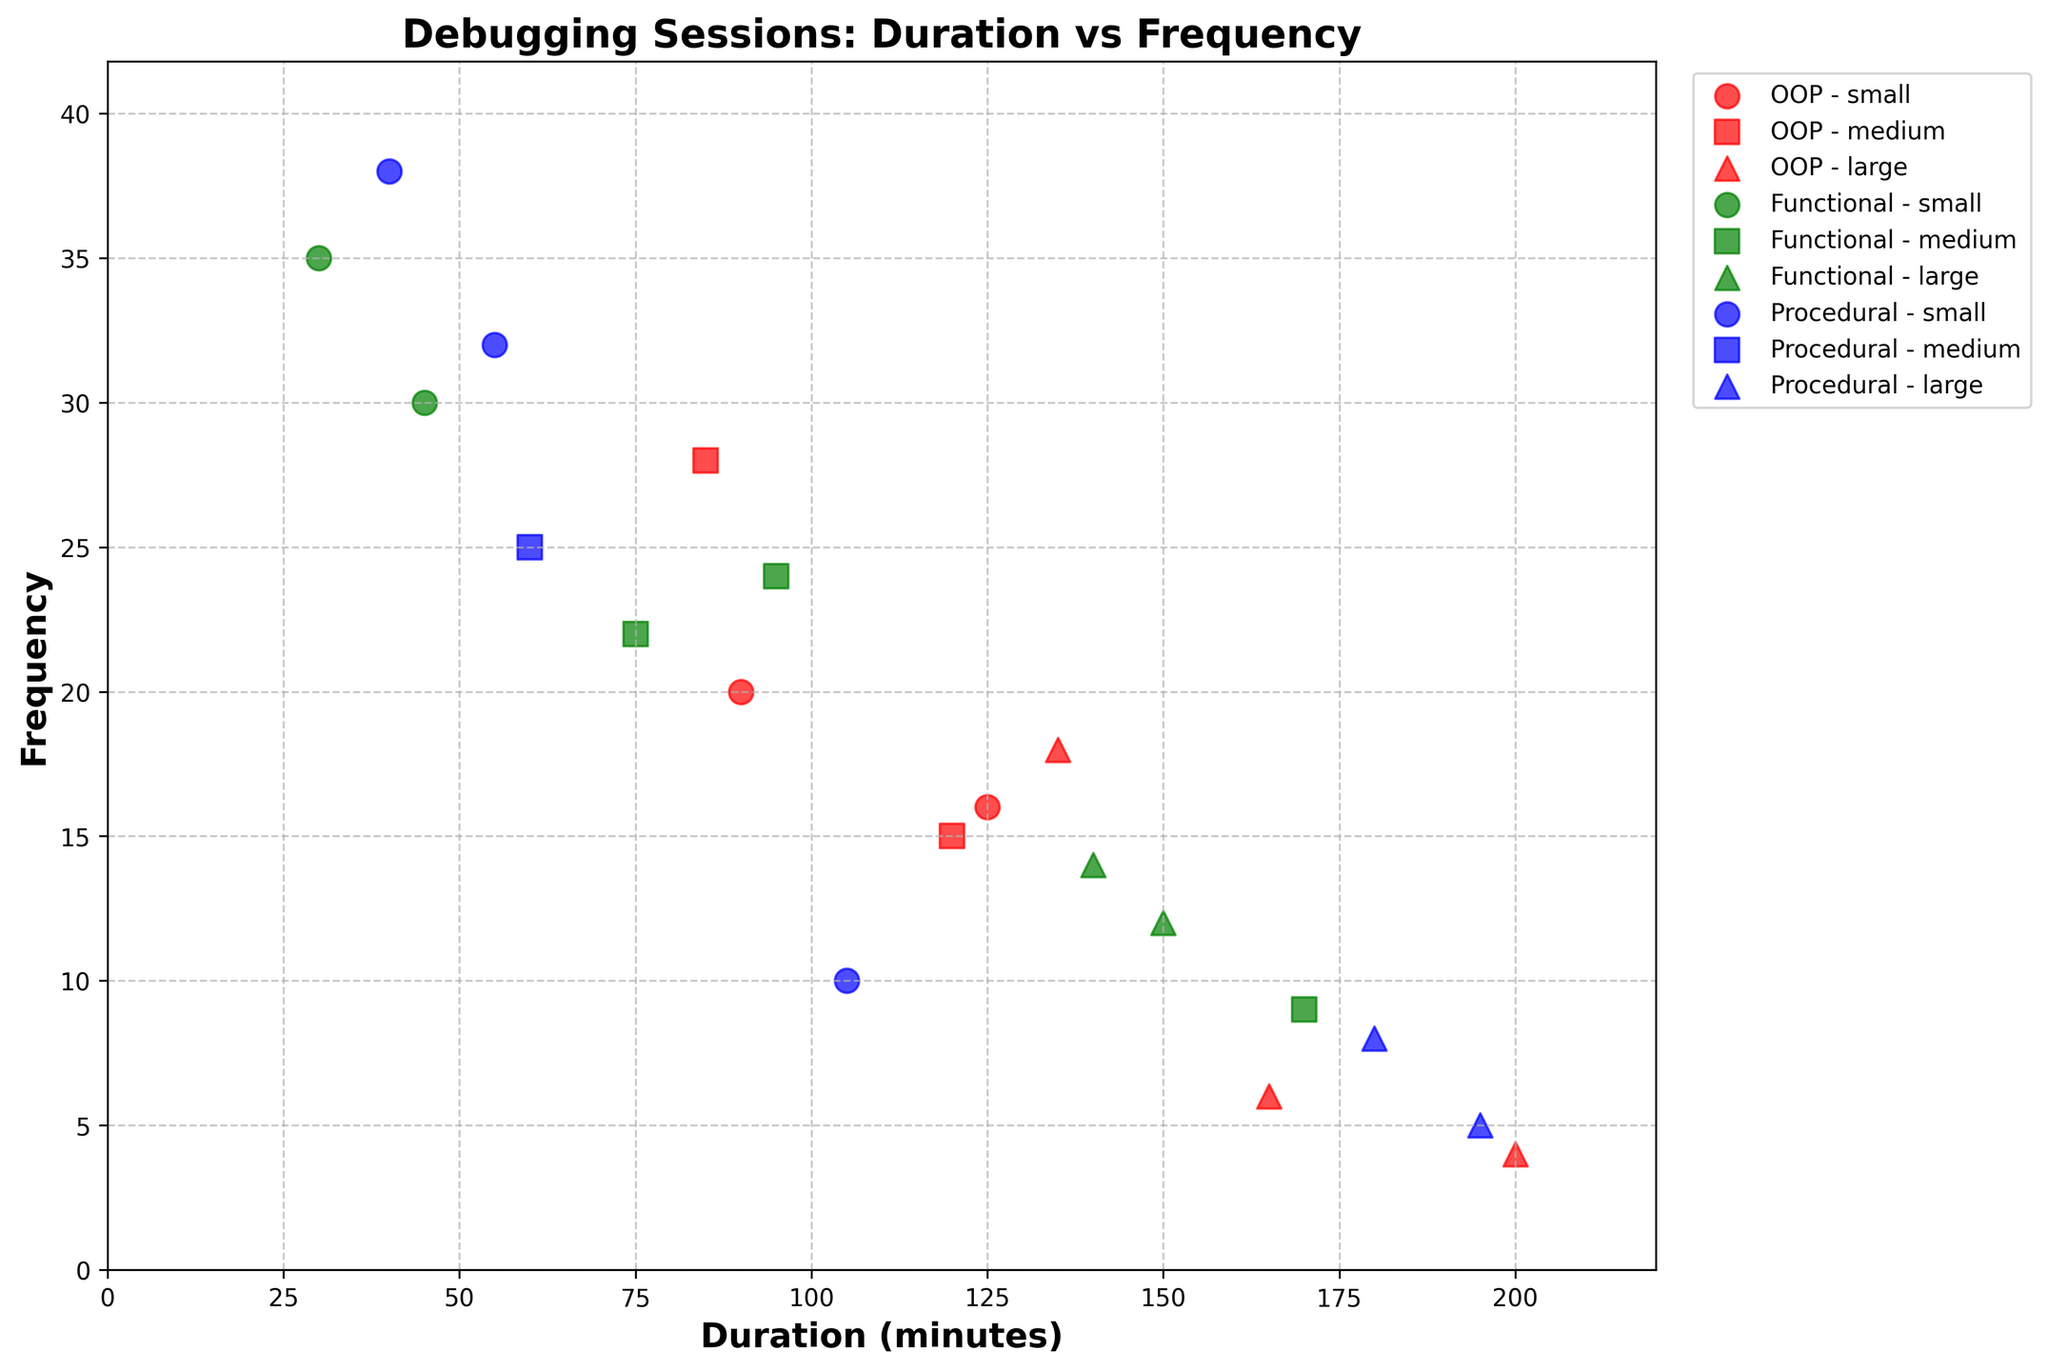What is the title of the plot? The title of the plot is typically located at the top center of the figure. By reading this area, we can identify the title easily.
Answer: Debugging Sessions: Duration vs Frequency How many unique colors are used to represent different programming paradigms? By looking at the different colors used in the plot, and since three paradigms are plotted, we can count the number of unique colors used.
Answer: Three Which programming paradigm generally has the highest debugging frequency? From the plot, we can observe the frequencies on the vertical axis and note the points where they are highest. Then, we check which colored markers represent these points.
Answer: Functional What is the range of durations for Procedural programming projects? By examining the x-axis values corresponding to the blue markers (Procedural), we can identify the minimum and maximum values for these points.
Answer: 30 to 200 Which project size in OOP has the highest debugging frequency? First, identify the red markers (OOP) and note down the shapes representing different project sizes. Then find the point with the highest frequency.
Answer: Medium What's the average frequency of debugging sessions for small Functional programming projects? Locate the green 'o' markers for small Functional projects, sum their frequencies, and divide by the number of such points. (30 + 35) / 2 = 32.5
Answer: 32.5 For large projects, which programming paradigm has the longest debugging duration? Look for the 'large' marker shapes (triangles) and compare the x-axis values (duration) of each programming paradigm for these shapes.
Answer: OOP How does the frequency of large OOP projects compare to the frequency of large Procedural projects? Compare the frequencies (y-axis values) of the large project markers (triangles) for OOP (red) and Procedural (blue).
Answer: OOP has lower frequency In terms of duration, which paradigm shows the most variability in debugging sessions? Observe the spread of marker positions along the x-axis for each color. The broader the spread, the greater the variability.
Answer: OOP Which project sizes show the least variation in frequency among the different paradigms? Check the y-axis (frequency) spread of markers for each shape that represents different project sizes. The smallest spread indicates less variability.
Answer: Large 